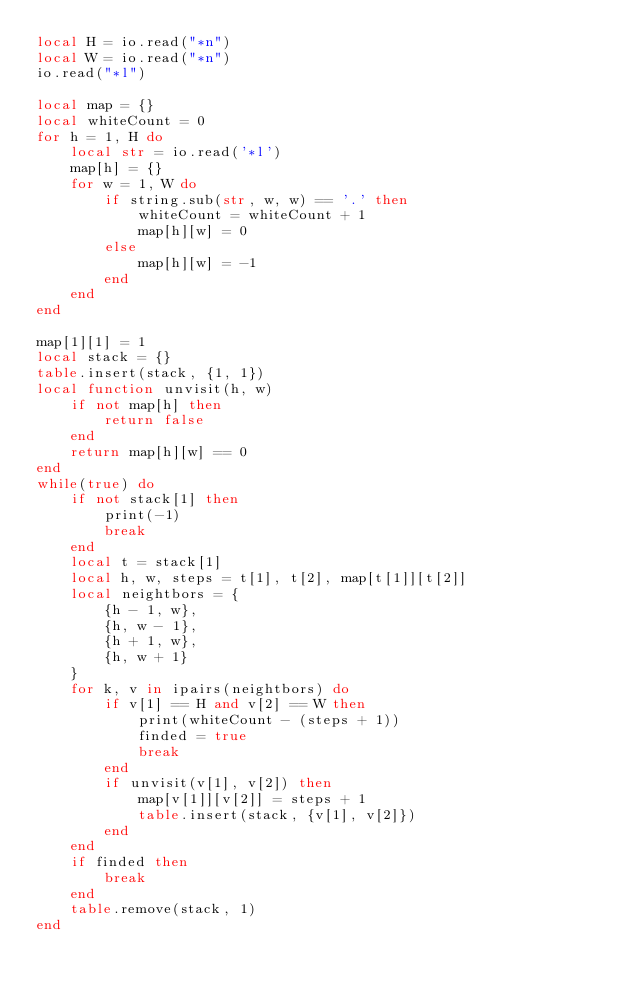Convert code to text. <code><loc_0><loc_0><loc_500><loc_500><_Lua_>local H = io.read("*n")
local W = io.read("*n")
io.read("*l")

local map = {}
local whiteCount = 0
for h = 1, H do
	local str = io.read('*l')
	map[h] = {}
	for w = 1, W do
		if string.sub(str, w, w) == '.' then
			whiteCount = whiteCount + 1
			map[h][w] = 0
		else
			map[h][w] = -1
		end
	end
end

map[1][1] = 1
local stack = {}
table.insert(stack, {1, 1})
local function unvisit(h, w)
	if not map[h] then
		return false
	end
	return map[h][w] == 0
end
while(true) do
	if not stack[1] then
		print(-1)
		break
	end
	local t = stack[1]
	local h, w, steps = t[1], t[2], map[t[1]][t[2]]
	local neightbors = {
		{h - 1, w},
		{h, w - 1},
		{h + 1, w},
		{h, w + 1}
	}
	for k, v in ipairs(neightbors) do
		if v[1] == H and v[2] == W then
			print(whiteCount - (steps + 1))
			finded = true
			break
		end
		if unvisit(v[1], v[2]) then
			map[v[1]][v[2]] = steps + 1
			table.insert(stack, {v[1], v[2]})
		end
	end
	if finded then
		break
	end
	table.remove(stack, 1)
end</code> 